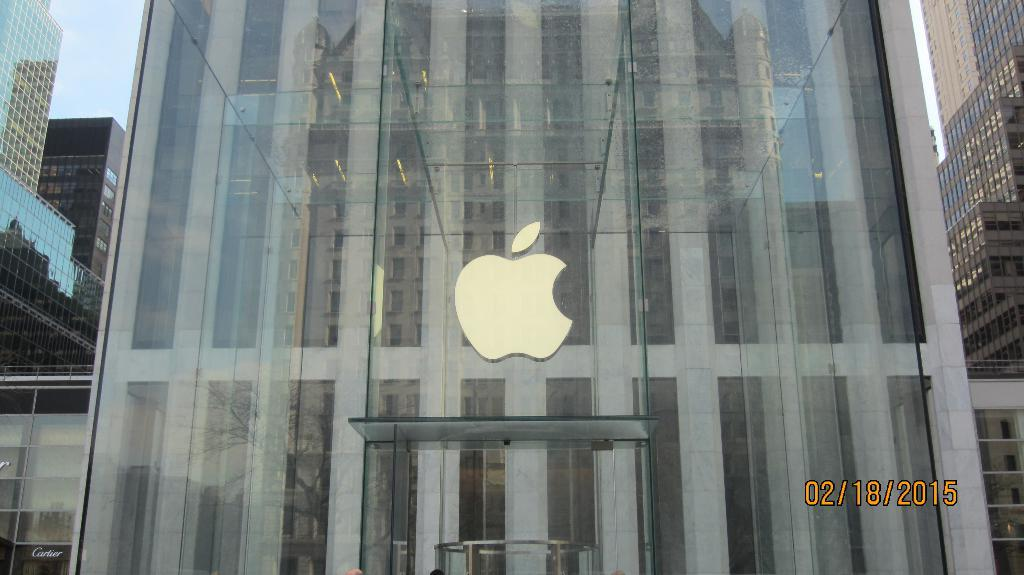What type of structures can be seen in the image? There are buildings in the image. What is located in the middle of the image? There is a logo in the middle of the image. Where can the date be found in the image? The date is in the bottom right of the image. How many apples are hanging from the net in the image? There is no net or apples present in the image. What type of war is depicted in the image? There is no war or any related imagery present in the image. 